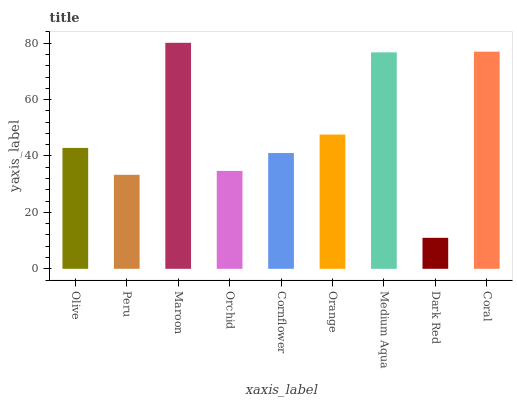Is Dark Red the minimum?
Answer yes or no. Yes. Is Maroon the maximum?
Answer yes or no. Yes. Is Peru the minimum?
Answer yes or no. No. Is Peru the maximum?
Answer yes or no. No. Is Olive greater than Peru?
Answer yes or no. Yes. Is Peru less than Olive?
Answer yes or no. Yes. Is Peru greater than Olive?
Answer yes or no. No. Is Olive less than Peru?
Answer yes or no. No. Is Olive the high median?
Answer yes or no. Yes. Is Olive the low median?
Answer yes or no. Yes. Is Peru the high median?
Answer yes or no. No. Is Maroon the low median?
Answer yes or no. No. 